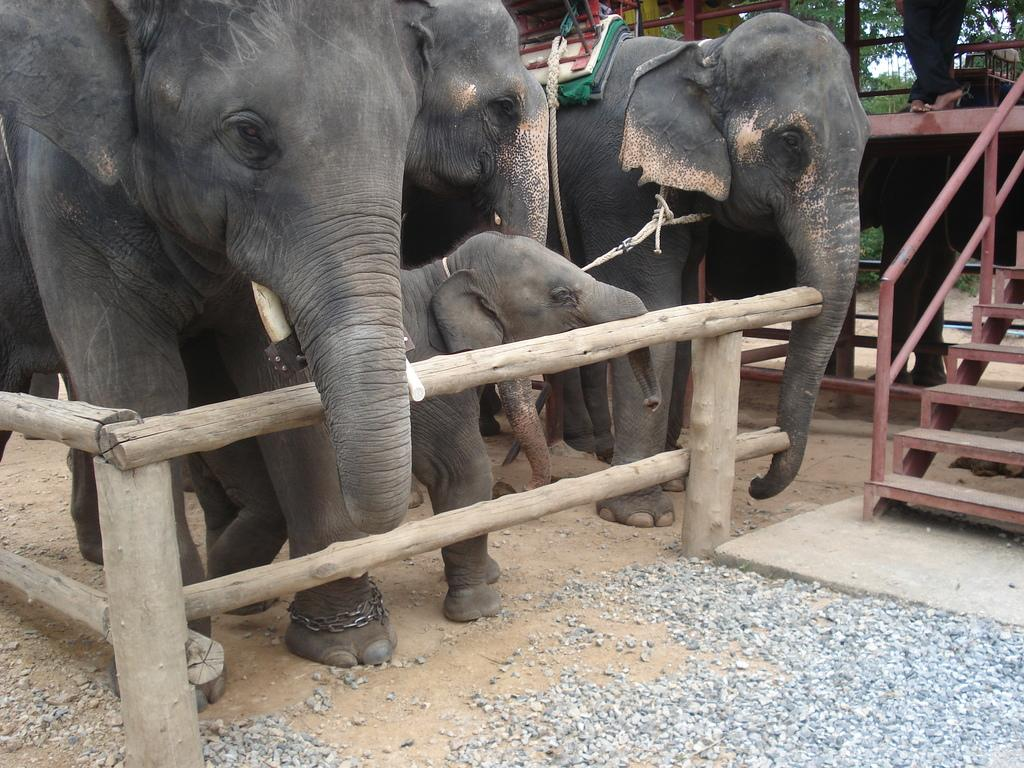What animals can be seen in the image? There are elephants in the image. What type of barrier is present in the image? There is a fence in the image. What type of natural elements can be seen in the image? There are stones and trees visible in the image. What architectural feature is present in the image? There is a staircase in the image. What part of a person can be seen at the top of the image? At the top of the image, there are legs of a person visible. What is visible in the sky at the top of the image? The sky is visible at the top of the image. How many roses can be seen in the image? There are no roses present in the image. What type of shoes is the person wearing at the top of the image? There is no information about the person's shoes in the image. 